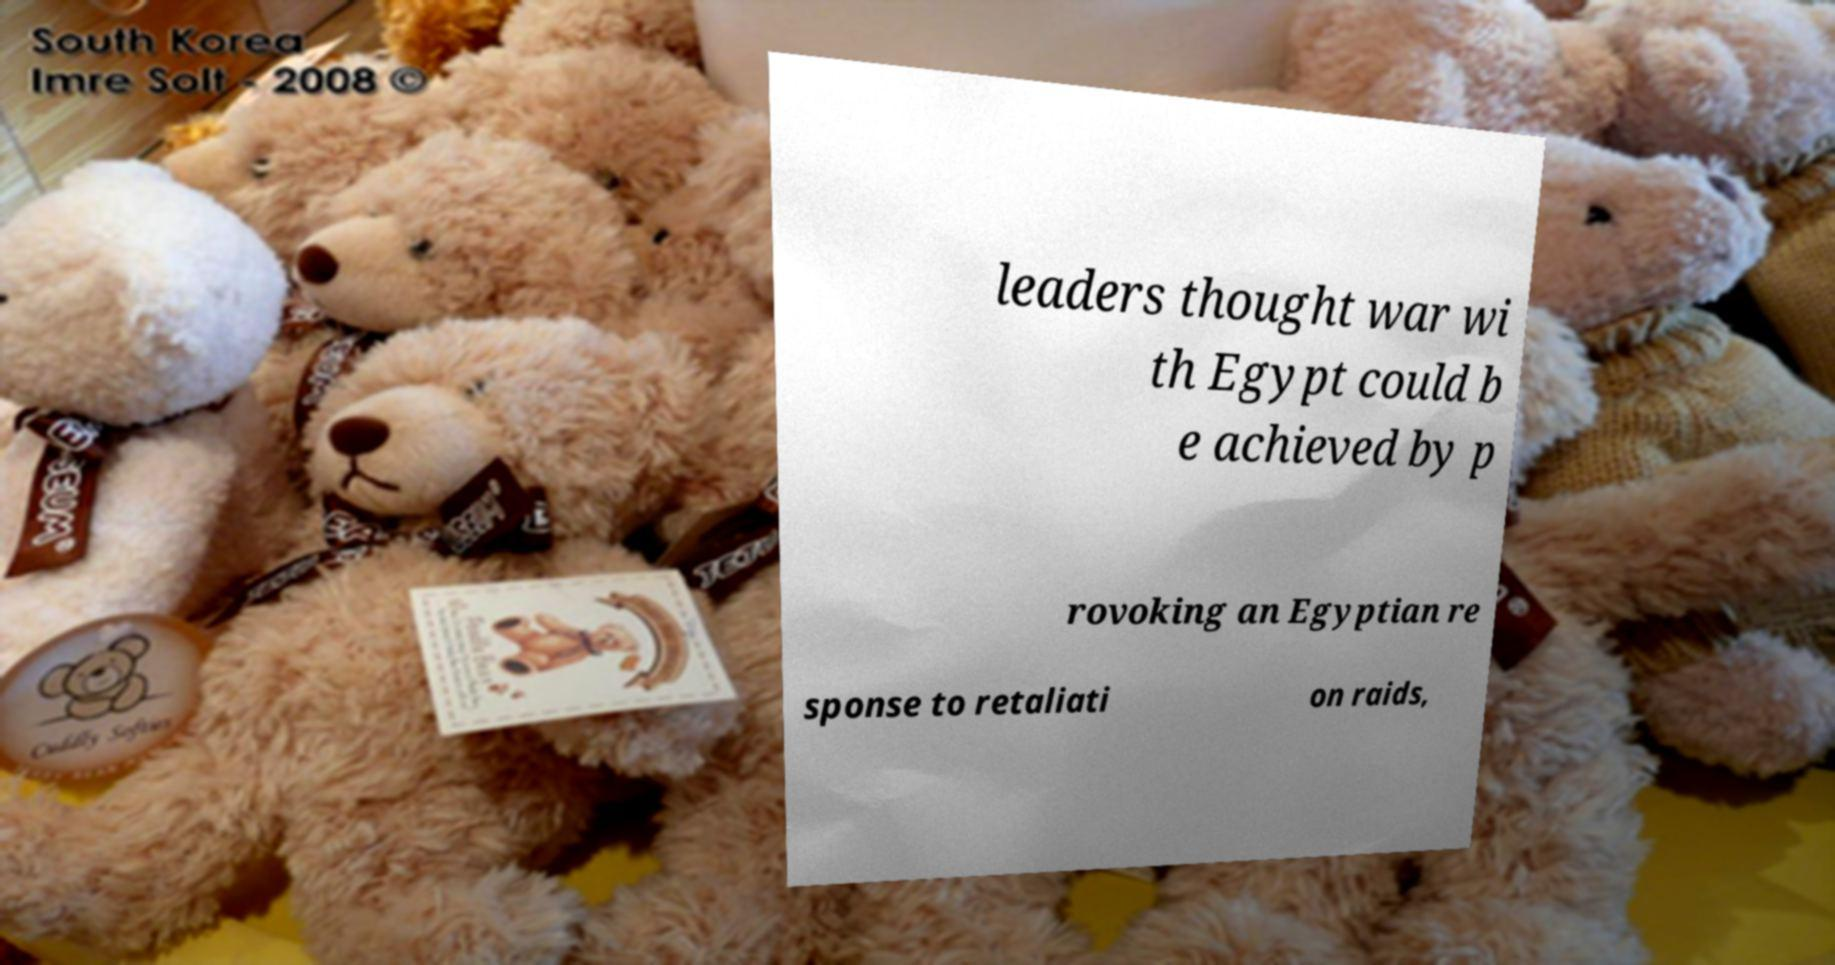Can you read and provide the text displayed in the image?This photo seems to have some interesting text. Can you extract and type it out for me? leaders thought war wi th Egypt could b e achieved by p rovoking an Egyptian re sponse to retaliati on raids, 